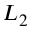<formula> <loc_0><loc_0><loc_500><loc_500>L _ { 2 }</formula> 